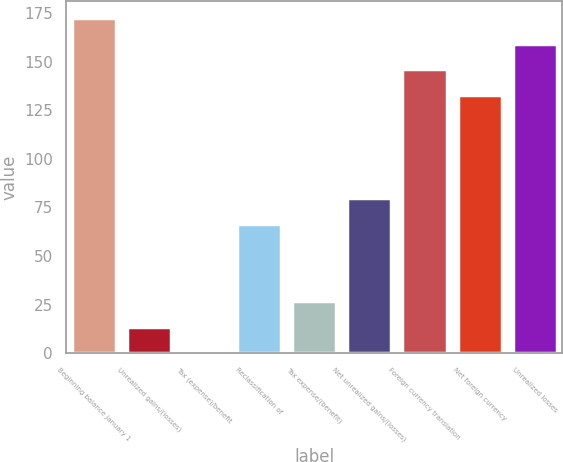<chart> <loc_0><loc_0><loc_500><loc_500><bar_chart><fcel>Beginning balance January 1<fcel>Unrealized gains/(losses)<fcel>Tax (expense)/benefit<fcel>Reclassification of<fcel>Tax expense/(benefit)<fcel>Net unrealized gains/(losses)<fcel>Foreign currency translation<fcel>Net foreign currency<fcel>Unrealized losses<nl><fcel>172.61<fcel>13.37<fcel>0.1<fcel>66.45<fcel>26.64<fcel>79.72<fcel>146.07<fcel>132.8<fcel>159.34<nl></chart> 